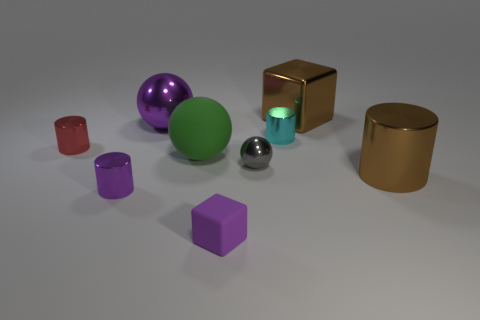What shape is the green matte object?
Your response must be concise. Sphere. What is the size of the metallic cylinder that is the same color as the large metal cube?
Provide a short and direct response. Large. What is the color of the large sphere that is made of the same material as the small red object?
Offer a very short reply. Purple. Are the big purple thing and the cube in front of the small ball made of the same material?
Your response must be concise. No. The big metal cube is what color?
Your answer should be compact. Brown. The gray thing that is made of the same material as the large brown block is what size?
Provide a short and direct response. Small. There is a ball to the right of the large sphere in front of the big metallic sphere; what number of metallic objects are behind it?
Provide a succinct answer. 4. There is a shiny block; is its color the same as the large metal thing in front of the red object?
Provide a short and direct response. Yes. What is the shape of the big object that is the same color as the matte block?
Your answer should be compact. Sphere. The sphere that is on the right side of the small purple thing that is right of the purple metallic object in front of the purple metallic ball is made of what material?
Your answer should be very brief. Metal. 